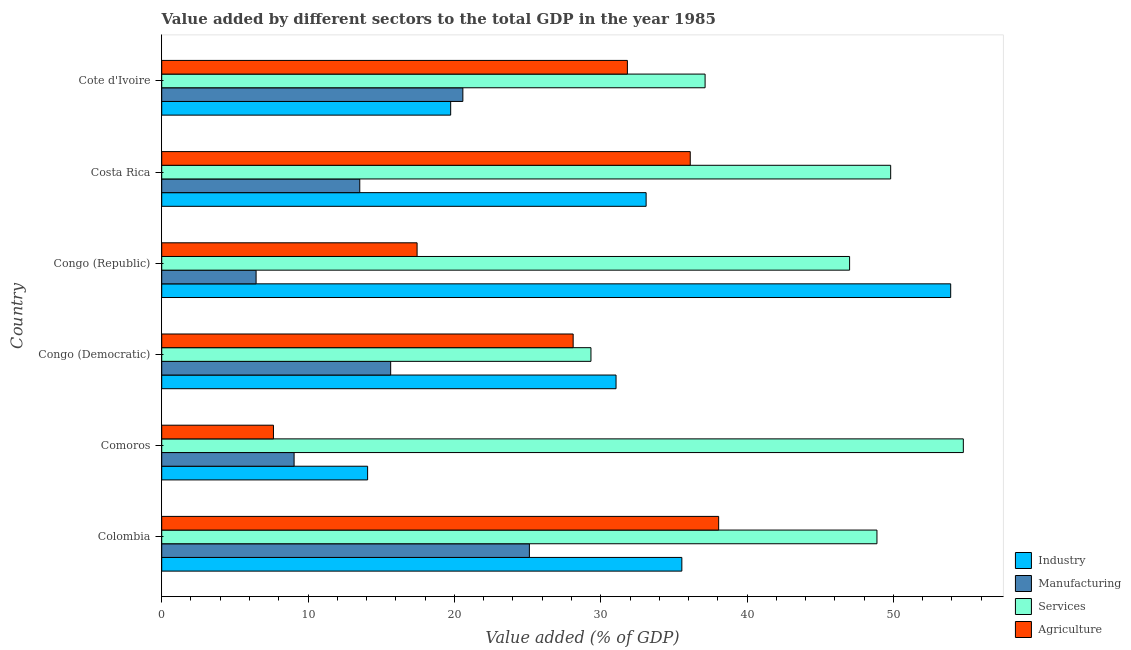How many different coloured bars are there?
Offer a very short reply. 4. How many groups of bars are there?
Your answer should be very brief. 6. What is the label of the 3rd group of bars from the top?
Your answer should be very brief. Congo (Republic). In how many cases, is the number of bars for a given country not equal to the number of legend labels?
Provide a short and direct response. 0. What is the value added by manufacturing sector in Colombia?
Your response must be concise. 25.12. Across all countries, what is the maximum value added by industrial sector?
Make the answer very short. 53.91. Across all countries, what is the minimum value added by services sector?
Your answer should be compact. 29.33. In which country was the value added by industrial sector maximum?
Your answer should be compact. Congo (Republic). In which country was the value added by industrial sector minimum?
Your answer should be very brief. Comoros. What is the total value added by manufacturing sector in the graph?
Provide a succinct answer. 90.38. What is the difference between the value added by industrial sector in Colombia and that in Congo (Democratic)?
Provide a succinct answer. 4.5. What is the difference between the value added by industrial sector in Costa Rica and the value added by services sector in Congo (Democratic)?
Your answer should be compact. 3.77. What is the average value added by services sector per country?
Your response must be concise. 44.49. What is the difference between the value added by industrial sector and value added by services sector in Cote d'Ivoire?
Keep it short and to the point. -17.39. In how many countries, is the value added by industrial sector greater than 4 %?
Provide a succinct answer. 6. What is the ratio of the value added by agricultural sector in Congo (Democratic) to that in Costa Rica?
Offer a terse response. 0.78. What is the difference between the highest and the second highest value added by services sector?
Offer a very short reply. 4.96. What is the difference between the highest and the lowest value added by agricultural sector?
Your answer should be compact. 30.42. Is the sum of the value added by agricultural sector in Congo (Democratic) and Cote d'Ivoire greater than the maximum value added by manufacturing sector across all countries?
Provide a succinct answer. Yes. What does the 1st bar from the top in Costa Rica represents?
Provide a short and direct response. Agriculture. What does the 1st bar from the bottom in Comoros represents?
Provide a short and direct response. Industry. Is it the case that in every country, the sum of the value added by industrial sector and value added by manufacturing sector is greater than the value added by services sector?
Your answer should be very brief. No. How many bars are there?
Give a very brief answer. 24. How many countries are there in the graph?
Your response must be concise. 6. What is the difference between two consecutive major ticks on the X-axis?
Your response must be concise. 10. Does the graph contain any zero values?
Give a very brief answer. No. Does the graph contain grids?
Give a very brief answer. No. How many legend labels are there?
Make the answer very short. 4. What is the title of the graph?
Ensure brevity in your answer.  Value added by different sectors to the total GDP in the year 1985. What is the label or title of the X-axis?
Give a very brief answer. Value added (% of GDP). What is the label or title of the Y-axis?
Your answer should be very brief. Country. What is the Value added (% of GDP) in Industry in Colombia?
Your response must be concise. 35.54. What is the Value added (% of GDP) in Manufacturing in Colombia?
Your answer should be compact. 25.12. What is the Value added (% of GDP) of Services in Colombia?
Provide a succinct answer. 48.88. What is the Value added (% of GDP) of Agriculture in Colombia?
Ensure brevity in your answer.  38.06. What is the Value added (% of GDP) of Industry in Comoros?
Offer a very short reply. 14.07. What is the Value added (% of GDP) in Manufacturing in Comoros?
Provide a short and direct response. 9.05. What is the Value added (% of GDP) of Services in Comoros?
Your answer should be compact. 54.78. What is the Value added (% of GDP) in Agriculture in Comoros?
Offer a terse response. 7.64. What is the Value added (% of GDP) of Industry in Congo (Democratic)?
Make the answer very short. 31.05. What is the Value added (% of GDP) in Manufacturing in Congo (Democratic)?
Give a very brief answer. 15.65. What is the Value added (% of GDP) of Services in Congo (Democratic)?
Make the answer very short. 29.33. What is the Value added (% of GDP) in Agriculture in Congo (Democratic)?
Provide a short and direct response. 28.12. What is the Value added (% of GDP) in Industry in Congo (Republic)?
Your response must be concise. 53.91. What is the Value added (% of GDP) in Manufacturing in Congo (Republic)?
Offer a very short reply. 6.45. What is the Value added (% of GDP) in Services in Congo (Republic)?
Your answer should be very brief. 47.01. What is the Value added (% of GDP) of Agriculture in Congo (Republic)?
Your answer should be compact. 17.45. What is the Value added (% of GDP) of Industry in Costa Rica?
Keep it short and to the point. 33.1. What is the Value added (% of GDP) of Manufacturing in Costa Rica?
Ensure brevity in your answer.  13.53. What is the Value added (% of GDP) of Services in Costa Rica?
Give a very brief answer. 49.81. What is the Value added (% of GDP) in Agriculture in Costa Rica?
Your answer should be very brief. 36.12. What is the Value added (% of GDP) in Industry in Cote d'Ivoire?
Provide a short and direct response. 19.75. What is the Value added (% of GDP) in Manufacturing in Cote d'Ivoire?
Offer a very short reply. 20.58. What is the Value added (% of GDP) in Services in Cote d'Ivoire?
Your answer should be compact. 37.13. What is the Value added (% of GDP) of Agriculture in Cote d'Ivoire?
Keep it short and to the point. 31.82. Across all countries, what is the maximum Value added (% of GDP) of Industry?
Ensure brevity in your answer.  53.91. Across all countries, what is the maximum Value added (% of GDP) in Manufacturing?
Ensure brevity in your answer.  25.12. Across all countries, what is the maximum Value added (% of GDP) in Services?
Make the answer very short. 54.78. Across all countries, what is the maximum Value added (% of GDP) in Agriculture?
Make the answer very short. 38.06. Across all countries, what is the minimum Value added (% of GDP) of Industry?
Offer a very short reply. 14.07. Across all countries, what is the minimum Value added (% of GDP) of Manufacturing?
Your response must be concise. 6.45. Across all countries, what is the minimum Value added (% of GDP) in Services?
Keep it short and to the point. 29.33. Across all countries, what is the minimum Value added (% of GDP) in Agriculture?
Provide a short and direct response. 7.64. What is the total Value added (% of GDP) of Industry in the graph?
Offer a very short reply. 187.42. What is the total Value added (% of GDP) in Manufacturing in the graph?
Ensure brevity in your answer.  90.38. What is the total Value added (% of GDP) of Services in the graph?
Keep it short and to the point. 266.94. What is the total Value added (% of GDP) of Agriculture in the graph?
Provide a short and direct response. 159.2. What is the difference between the Value added (% of GDP) of Industry in Colombia and that in Comoros?
Offer a very short reply. 21.47. What is the difference between the Value added (% of GDP) of Manufacturing in Colombia and that in Comoros?
Ensure brevity in your answer.  16.08. What is the difference between the Value added (% of GDP) in Services in Colombia and that in Comoros?
Provide a succinct answer. -5.9. What is the difference between the Value added (% of GDP) in Agriculture in Colombia and that in Comoros?
Offer a terse response. 30.42. What is the difference between the Value added (% of GDP) in Industry in Colombia and that in Congo (Democratic)?
Give a very brief answer. 4.5. What is the difference between the Value added (% of GDP) in Manufacturing in Colombia and that in Congo (Democratic)?
Your answer should be very brief. 9.48. What is the difference between the Value added (% of GDP) in Services in Colombia and that in Congo (Democratic)?
Offer a very short reply. 19.54. What is the difference between the Value added (% of GDP) of Agriculture in Colombia and that in Congo (Democratic)?
Your answer should be compact. 9.94. What is the difference between the Value added (% of GDP) in Industry in Colombia and that in Congo (Republic)?
Your answer should be compact. -18.37. What is the difference between the Value added (% of GDP) in Manufacturing in Colombia and that in Congo (Republic)?
Your answer should be very brief. 18.68. What is the difference between the Value added (% of GDP) in Services in Colombia and that in Congo (Republic)?
Provide a succinct answer. 1.87. What is the difference between the Value added (% of GDP) of Agriculture in Colombia and that in Congo (Republic)?
Your answer should be compact. 20.61. What is the difference between the Value added (% of GDP) in Industry in Colombia and that in Costa Rica?
Your answer should be compact. 2.44. What is the difference between the Value added (% of GDP) of Manufacturing in Colombia and that in Costa Rica?
Offer a very short reply. 11.59. What is the difference between the Value added (% of GDP) of Services in Colombia and that in Costa Rica?
Ensure brevity in your answer.  -0.94. What is the difference between the Value added (% of GDP) of Agriculture in Colombia and that in Costa Rica?
Provide a short and direct response. 1.94. What is the difference between the Value added (% of GDP) of Industry in Colombia and that in Cote d'Ivoire?
Keep it short and to the point. 15.8. What is the difference between the Value added (% of GDP) in Manufacturing in Colombia and that in Cote d'Ivoire?
Your answer should be very brief. 4.55. What is the difference between the Value added (% of GDP) of Services in Colombia and that in Cote d'Ivoire?
Keep it short and to the point. 11.74. What is the difference between the Value added (% of GDP) of Agriculture in Colombia and that in Cote d'Ivoire?
Provide a succinct answer. 6.24. What is the difference between the Value added (% of GDP) in Industry in Comoros and that in Congo (Democratic)?
Your answer should be very brief. -16.98. What is the difference between the Value added (% of GDP) in Manufacturing in Comoros and that in Congo (Democratic)?
Your response must be concise. -6.6. What is the difference between the Value added (% of GDP) in Services in Comoros and that in Congo (Democratic)?
Give a very brief answer. 25.45. What is the difference between the Value added (% of GDP) in Agriculture in Comoros and that in Congo (Democratic)?
Your response must be concise. -20.48. What is the difference between the Value added (% of GDP) of Industry in Comoros and that in Congo (Republic)?
Provide a short and direct response. -39.84. What is the difference between the Value added (% of GDP) of Manufacturing in Comoros and that in Congo (Republic)?
Offer a very short reply. 2.6. What is the difference between the Value added (% of GDP) of Services in Comoros and that in Congo (Republic)?
Make the answer very short. 7.77. What is the difference between the Value added (% of GDP) of Agriculture in Comoros and that in Congo (Republic)?
Your answer should be very brief. -9.82. What is the difference between the Value added (% of GDP) of Industry in Comoros and that in Costa Rica?
Your response must be concise. -19.03. What is the difference between the Value added (% of GDP) in Manufacturing in Comoros and that in Costa Rica?
Keep it short and to the point. -4.49. What is the difference between the Value added (% of GDP) in Services in Comoros and that in Costa Rica?
Make the answer very short. 4.96. What is the difference between the Value added (% of GDP) of Agriculture in Comoros and that in Costa Rica?
Give a very brief answer. -28.48. What is the difference between the Value added (% of GDP) of Industry in Comoros and that in Cote d'Ivoire?
Provide a succinct answer. -5.68. What is the difference between the Value added (% of GDP) of Manufacturing in Comoros and that in Cote d'Ivoire?
Your response must be concise. -11.53. What is the difference between the Value added (% of GDP) of Services in Comoros and that in Cote d'Ivoire?
Provide a succinct answer. 17.65. What is the difference between the Value added (% of GDP) of Agriculture in Comoros and that in Cote d'Ivoire?
Make the answer very short. -24.19. What is the difference between the Value added (% of GDP) in Industry in Congo (Democratic) and that in Congo (Republic)?
Keep it short and to the point. -22.87. What is the difference between the Value added (% of GDP) in Manufacturing in Congo (Democratic) and that in Congo (Republic)?
Make the answer very short. 9.2. What is the difference between the Value added (% of GDP) of Services in Congo (Democratic) and that in Congo (Republic)?
Give a very brief answer. -17.67. What is the difference between the Value added (% of GDP) of Agriculture in Congo (Democratic) and that in Congo (Republic)?
Give a very brief answer. 10.66. What is the difference between the Value added (% of GDP) of Industry in Congo (Democratic) and that in Costa Rica?
Your response must be concise. -2.06. What is the difference between the Value added (% of GDP) of Manufacturing in Congo (Democratic) and that in Costa Rica?
Ensure brevity in your answer.  2.11. What is the difference between the Value added (% of GDP) of Services in Congo (Democratic) and that in Costa Rica?
Your answer should be compact. -20.48. What is the difference between the Value added (% of GDP) of Agriculture in Congo (Democratic) and that in Costa Rica?
Offer a very short reply. -8. What is the difference between the Value added (% of GDP) of Industry in Congo (Democratic) and that in Cote d'Ivoire?
Ensure brevity in your answer.  11.3. What is the difference between the Value added (% of GDP) in Manufacturing in Congo (Democratic) and that in Cote d'Ivoire?
Ensure brevity in your answer.  -4.93. What is the difference between the Value added (% of GDP) in Services in Congo (Democratic) and that in Cote d'Ivoire?
Give a very brief answer. -7.8. What is the difference between the Value added (% of GDP) in Agriculture in Congo (Democratic) and that in Cote d'Ivoire?
Make the answer very short. -3.71. What is the difference between the Value added (% of GDP) of Industry in Congo (Republic) and that in Costa Rica?
Your response must be concise. 20.81. What is the difference between the Value added (% of GDP) in Manufacturing in Congo (Republic) and that in Costa Rica?
Your answer should be very brief. -7.08. What is the difference between the Value added (% of GDP) of Services in Congo (Republic) and that in Costa Rica?
Your answer should be very brief. -2.81. What is the difference between the Value added (% of GDP) of Agriculture in Congo (Republic) and that in Costa Rica?
Ensure brevity in your answer.  -18.67. What is the difference between the Value added (% of GDP) in Industry in Congo (Republic) and that in Cote d'Ivoire?
Keep it short and to the point. 34.17. What is the difference between the Value added (% of GDP) of Manufacturing in Congo (Republic) and that in Cote d'Ivoire?
Provide a short and direct response. -14.13. What is the difference between the Value added (% of GDP) of Services in Congo (Republic) and that in Cote d'Ivoire?
Your answer should be very brief. 9.87. What is the difference between the Value added (% of GDP) of Agriculture in Congo (Republic) and that in Cote d'Ivoire?
Provide a short and direct response. -14.37. What is the difference between the Value added (% of GDP) in Industry in Costa Rica and that in Cote d'Ivoire?
Make the answer very short. 13.36. What is the difference between the Value added (% of GDP) in Manufacturing in Costa Rica and that in Cote d'Ivoire?
Keep it short and to the point. -7.04. What is the difference between the Value added (% of GDP) of Services in Costa Rica and that in Cote d'Ivoire?
Ensure brevity in your answer.  12.68. What is the difference between the Value added (% of GDP) in Agriculture in Costa Rica and that in Cote d'Ivoire?
Offer a terse response. 4.3. What is the difference between the Value added (% of GDP) in Industry in Colombia and the Value added (% of GDP) in Manufacturing in Comoros?
Ensure brevity in your answer.  26.5. What is the difference between the Value added (% of GDP) of Industry in Colombia and the Value added (% of GDP) of Services in Comoros?
Offer a terse response. -19.24. What is the difference between the Value added (% of GDP) of Industry in Colombia and the Value added (% of GDP) of Agriculture in Comoros?
Keep it short and to the point. 27.91. What is the difference between the Value added (% of GDP) in Manufacturing in Colombia and the Value added (% of GDP) in Services in Comoros?
Ensure brevity in your answer.  -29.65. What is the difference between the Value added (% of GDP) of Manufacturing in Colombia and the Value added (% of GDP) of Agriculture in Comoros?
Provide a short and direct response. 17.49. What is the difference between the Value added (% of GDP) of Services in Colombia and the Value added (% of GDP) of Agriculture in Comoros?
Offer a terse response. 41.24. What is the difference between the Value added (% of GDP) of Industry in Colombia and the Value added (% of GDP) of Manufacturing in Congo (Democratic)?
Make the answer very short. 19.9. What is the difference between the Value added (% of GDP) in Industry in Colombia and the Value added (% of GDP) in Services in Congo (Democratic)?
Offer a very short reply. 6.21. What is the difference between the Value added (% of GDP) in Industry in Colombia and the Value added (% of GDP) in Agriculture in Congo (Democratic)?
Your answer should be very brief. 7.43. What is the difference between the Value added (% of GDP) of Manufacturing in Colombia and the Value added (% of GDP) of Services in Congo (Democratic)?
Ensure brevity in your answer.  -4.21. What is the difference between the Value added (% of GDP) of Manufacturing in Colombia and the Value added (% of GDP) of Agriculture in Congo (Democratic)?
Make the answer very short. -2.99. What is the difference between the Value added (% of GDP) in Services in Colombia and the Value added (% of GDP) in Agriculture in Congo (Democratic)?
Offer a very short reply. 20.76. What is the difference between the Value added (% of GDP) in Industry in Colombia and the Value added (% of GDP) in Manufacturing in Congo (Republic)?
Make the answer very short. 29.09. What is the difference between the Value added (% of GDP) in Industry in Colombia and the Value added (% of GDP) in Services in Congo (Republic)?
Provide a short and direct response. -11.46. What is the difference between the Value added (% of GDP) of Industry in Colombia and the Value added (% of GDP) of Agriculture in Congo (Republic)?
Give a very brief answer. 18.09. What is the difference between the Value added (% of GDP) in Manufacturing in Colombia and the Value added (% of GDP) in Services in Congo (Republic)?
Your answer should be compact. -21.88. What is the difference between the Value added (% of GDP) of Manufacturing in Colombia and the Value added (% of GDP) of Agriculture in Congo (Republic)?
Ensure brevity in your answer.  7.67. What is the difference between the Value added (% of GDP) in Services in Colombia and the Value added (% of GDP) in Agriculture in Congo (Republic)?
Make the answer very short. 31.42. What is the difference between the Value added (% of GDP) of Industry in Colombia and the Value added (% of GDP) of Manufacturing in Costa Rica?
Offer a very short reply. 22.01. What is the difference between the Value added (% of GDP) of Industry in Colombia and the Value added (% of GDP) of Services in Costa Rica?
Provide a succinct answer. -14.27. What is the difference between the Value added (% of GDP) of Industry in Colombia and the Value added (% of GDP) of Agriculture in Costa Rica?
Your answer should be very brief. -0.57. What is the difference between the Value added (% of GDP) of Manufacturing in Colombia and the Value added (% of GDP) of Services in Costa Rica?
Offer a very short reply. -24.69. What is the difference between the Value added (% of GDP) in Manufacturing in Colombia and the Value added (% of GDP) in Agriculture in Costa Rica?
Make the answer very short. -10.99. What is the difference between the Value added (% of GDP) of Services in Colombia and the Value added (% of GDP) of Agriculture in Costa Rica?
Keep it short and to the point. 12.76. What is the difference between the Value added (% of GDP) in Industry in Colombia and the Value added (% of GDP) in Manufacturing in Cote d'Ivoire?
Keep it short and to the point. 14.96. What is the difference between the Value added (% of GDP) in Industry in Colombia and the Value added (% of GDP) in Services in Cote d'Ivoire?
Your answer should be very brief. -1.59. What is the difference between the Value added (% of GDP) of Industry in Colombia and the Value added (% of GDP) of Agriculture in Cote d'Ivoire?
Offer a very short reply. 3.72. What is the difference between the Value added (% of GDP) in Manufacturing in Colombia and the Value added (% of GDP) in Services in Cote d'Ivoire?
Your answer should be very brief. -12.01. What is the difference between the Value added (% of GDP) in Manufacturing in Colombia and the Value added (% of GDP) in Agriculture in Cote d'Ivoire?
Your answer should be compact. -6.7. What is the difference between the Value added (% of GDP) in Services in Colombia and the Value added (% of GDP) in Agriculture in Cote d'Ivoire?
Make the answer very short. 17.05. What is the difference between the Value added (% of GDP) in Industry in Comoros and the Value added (% of GDP) in Manufacturing in Congo (Democratic)?
Your response must be concise. -1.58. What is the difference between the Value added (% of GDP) in Industry in Comoros and the Value added (% of GDP) in Services in Congo (Democratic)?
Provide a short and direct response. -15.26. What is the difference between the Value added (% of GDP) in Industry in Comoros and the Value added (% of GDP) in Agriculture in Congo (Democratic)?
Offer a very short reply. -14.05. What is the difference between the Value added (% of GDP) of Manufacturing in Comoros and the Value added (% of GDP) of Services in Congo (Democratic)?
Offer a terse response. -20.29. What is the difference between the Value added (% of GDP) in Manufacturing in Comoros and the Value added (% of GDP) in Agriculture in Congo (Democratic)?
Keep it short and to the point. -19.07. What is the difference between the Value added (% of GDP) of Services in Comoros and the Value added (% of GDP) of Agriculture in Congo (Democratic)?
Your answer should be compact. 26.66. What is the difference between the Value added (% of GDP) in Industry in Comoros and the Value added (% of GDP) in Manufacturing in Congo (Republic)?
Provide a succinct answer. 7.62. What is the difference between the Value added (% of GDP) in Industry in Comoros and the Value added (% of GDP) in Services in Congo (Republic)?
Your response must be concise. -32.94. What is the difference between the Value added (% of GDP) of Industry in Comoros and the Value added (% of GDP) of Agriculture in Congo (Republic)?
Provide a short and direct response. -3.38. What is the difference between the Value added (% of GDP) of Manufacturing in Comoros and the Value added (% of GDP) of Services in Congo (Republic)?
Offer a very short reply. -37.96. What is the difference between the Value added (% of GDP) in Manufacturing in Comoros and the Value added (% of GDP) in Agriculture in Congo (Republic)?
Your response must be concise. -8.41. What is the difference between the Value added (% of GDP) in Services in Comoros and the Value added (% of GDP) in Agriculture in Congo (Republic)?
Provide a short and direct response. 37.33. What is the difference between the Value added (% of GDP) of Industry in Comoros and the Value added (% of GDP) of Manufacturing in Costa Rica?
Your answer should be very brief. 0.54. What is the difference between the Value added (% of GDP) in Industry in Comoros and the Value added (% of GDP) in Services in Costa Rica?
Keep it short and to the point. -35.74. What is the difference between the Value added (% of GDP) in Industry in Comoros and the Value added (% of GDP) in Agriculture in Costa Rica?
Make the answer very short. -22.05. What is the difference between the Value added (% of GDP) in Manufacturing in Comoros and the Value added (% of GDP) in Services in Costa Rica?
Offer a terse response. -40.77. What is the difference between the Value added (% of GDP) in Manufacturing in Comoros and the Value added (% of GDP) in Agriculture in Costa Rica?
Your response must be concise. -27.07. What is the difference between the Value added (% of GDP) of Services in Comoros and the Value added (% of GDP) of Agriculture in Costa Rica?
Ensure brevity in your answer.  18.66. What is the difference between the Value added (% of GDP) in Industry in Comoros and the Value added (% of GDP) in Manufacturing in Cote d'Ivoire?
Offer a very short reply. -6.51. What is the difference between the Value added (% of GDP) in Industry in Comoros and the Value added (% of GDP) in Services in Cote d'Ivoire?
Provide a succinct answer. -23.06. What is the difference between the Value added (% of GDP) of Industry in Comoros and the Value added (% of GDP) of Agriculture in Cote d'Ivoire?
Ensure brevity in your answer.  -17.75. What is the difference between the Value added (% of GDP) in Manufacturing in Comoros and the Value added (% of GDP) in Services in Cote d'Ivoire?
Keep it short and to the point. -28.09. What is the difference between the Value added (% of GDP) in Manufacturing in Comoros and the Value added (% of GDP) in Agriculture in Cote d'Ivoire?
Your response must be concise. -22.78. What is the difference between the Value added (% of GDP) in Services in Comoros and the Value added (% of GDP) in Agriculture in Cote d'Ivoire?
Your answer should be very brief. 22.96. What is the difference between the Value added (% of GDP) of Industry in Congo (Democratic) and the Value added (% of GDP) of Manufacturing in Congo (Republic)?
Your response must be concise. 24.6. What is the difference between the Value added (% of GDP) of Industry in Congo (Democratic) and the Value added (% of GDP) of Services in Congo (Republic)?
Your response must be concise. -15.96. What is the difference between the Value added (% of GDP) in Industry in Congo (Democratic) and the Value added (% of GDP) in Agriculture in Congo (Republic)?
Your answer should be compact. 13.59. What is the difference between the Value added (% of GDP) of Manufacturing in Congo (Democratic) and the Value added (% of GDP) of Services in Congo (Republic)?
Provide a succinct answer. -31.36. What is the difference between the Value added (% of GDP) of Manufacturing in Congo (Democratic) and the Value added (% of GDP) of Agriculture in Congo (Republic)?
Your answer should be very brief. -1.81. What is the difference between the Value added (% of GDP) in Services in Congo (Democratic) and the Value added (% of GDP) in Agriculture in Congo (Republic)?
Your response must be concise. 11.88. What is the difference between the Value added (% of GDP) of Industry in Congo (Democratic) and the Value added (% of GDP) of Manufacturing in Costa Rica?
Your answer should be compact. 17.51. What is the difference between the Value added (% of GDP) in Industry in Congo (Democratic) and the Value added (% of GDP) in Services in Costa Rica?
Provide a succinct answer. -18.77. What is the difference between the Value added (% of GDP) in Industry in Congo (Democratic) and the Value added (% of GDP) in Agriculture in Costa Rica?
Offer a very short reply. -5.07. What is the difference between the Value added (% of GDP) in Manufacturing in Congo (Democratic) and the Value added (% of GDP) in Services in Costa Rica?
Provide a short and direct response. -34.17. What is the difference between the Value added (% of GDP) of Manufacturing in Congo (Democratic) and the Value added (% of GDP) of Agriculture in Costa Rica?
Your answer should be very brief. -20.47. What is the difference between the Value added (% of GDP) of Services in Congo (Democratic) and the Value added (% of GDP) of Agriculture in Costa Rica?
Ensure brevity in your answer.  -6.78. What is the difference between the Value added (% of GDP) in Industry in Congo (Democratic) and the Value added (% of GDP) in Manufacturing in Cote d'Ivoire?
Your response must be concise. 10.47. What is the difference between the Value added (% of GDP) in Industry in Congo (Democratic) and the Value added (% of GDP) in Services in Cote d'Ivoire?
Give a very brief answer. -6.09. What is the difference between the Value added (% of GDP) in Industry in Congo (Democratic) and the Value added (% of GDP) in Agriculture in Cote d'Ivoire?
Your response must be concise. -0.78. What is the difference between the Value added (% of GDP) of Manufacturing in Congo (Democratic) and the Value added (% of GDP) of Services in Cote d'Ivoire?
Give a very brief answer. -21.49. What is the difference between the Value added (% of GDP) of Manufacturing in Congo (Democratic) and the Value added (% of GDP) of Agriculture in Cote d'Ivoire?
Provide a short and direct response. -16.18. What is the difference between the Value added (% of GDP) in Services in Congo (Democratic) and the Value added (% of GDP) in Agriculture in Cote d'Ivoire?
Your answer should be compact. -2.49. What is the difference between the Value added (% of GDP) in Industry in Congo (Republic) and the Value added (% of GDP) in Manufacturing in Costa Rica?
Provide a succinct answer. 40.38. What is the difference between the Value added (% of GDP) in Industry in Congo (Republic) and the Value added (% of GDP) in Services in Costa Rica?
Offer a terse response. 4.1. What is the difference between the Value added (% of GDP) in Industry in Congo (Republic) and the Value added (% of GDP) in Agriculture in Costa Rica?
Offer a terse response. 17.8. What is the difference between the Value added (% of GDP) in Manufacturing in Congo (Republic) and the Value added (% of GDP) in Services in Costa Rica?
Offer a terse response. -43.36. What is the difference between the Value added (% of GDP) in Manufacturing in Congo (Republic) and the Value added (% of GDP) in Agriculture in Costa Rica?
Offer a very short reply. -29.67. What is the difference between the Value added (% of GDP) of Services in Congo (Republic) and the Value added (% of GDP) of Agriculture in Costa Rica?
Give a very brief answer. 10.89. What is the difference between the Value added (% of GDP) in Industry in Congo (Republic) and the Value added (% of GDP) in Manufacturing in Cote d'Ivoire?
Give a very brief answer. 33.34. What is the difference between the Value added (% of GDP) in Industry in Congo (Republic) and the Value added (% of GDP) in Services in Cote d'Ivoire?
Ensure brevity in your answer.  16.78. What is the difference between the Value added (% of GDP) of Industry in Congo (Republic) and the Value added (% of GDP) of Agriculture in Cote d'Ivoire?
Offer a terse response. 22.09. What is the difference between the Value added (% of GDP) of Manufacturing in Congo (Republic) and the Value added (% of GDP) of Services in Cote d'Ivoire?
Provide a short and direct response. -30.68. What is the difference between the Value added (% of GDP) of Manufacturing in Congo (Republic) and the Value added (% of GDP) of Agriculture in Cote d'Ivoire?
Offer a terse response. -25.37. What is the difference between the Value added (% of GDP) of Services in Congo (Republic) and the Value added (% of GDP) of Agriculture in Cote d'Ivoire?
Your answer should be compact. 15.18. What is the difference between the Value added (% of GDP) in Industry in Costa Rica and the Value added (% of GDP) in Manufacturing in Cote d'Ivoire?
Keep it short and to the point. 12.52. What is the difference between the Value added (% of GDP) in Industry in Costa Rica and the Value added (% of GDP) in Services in Cote d'Ivoire?
Provide a succinct answer. -4.03. What is the difference between the Value added (% of GDP) of Industry in Costa Rica and the Value added (% of GDP) of Agriculture in Cote d'Ivoire?
Keep it short and to the point. 1.28. What is the difference between the Value added (% of GDP) of Manufacturing in Costa Rica and the Value added (% of GDP) of Services in Cote d'Ivoire?
Your answer should be compact. -23.6. What is the difference between the Value added (% of GDP) of Manufacturing in Costa Rica and the Value added (% of GDP) of Agriculture in Cote d'Ivoire?
Make the answer very short. -18.29. What is the difference between the Value added (% of GDP) in Services in Costa Rica and the Value added (% of GDP) in Agriculture in Cote d'Ivoire?
Ensure brevity in your answer.  17.99. What is the average Value added (% of GDP) of Industry per country?
Your answer should be compact. 31.24. What is the average Value added (% of GDP) of Manufacturing per country?
Ensure brevity in your answer.  15.06. What is the average Value added (% of GDP) in Services per country?
Provide a succinct answer. 44.49. What is the average Value added (% of GDP) in Agriculture per country?
Offer a very short reply. 26.53. What is the difference between the Value added (% of GDP) in Industry and Value added (% of GDP) in Manufacturing in Colombia?
Offer a terse response. 10.42. What is the difference between the Value added (% of GDP) in Industry and Value added (% of GDP) in Services in Colombia?
Offer a terse response. -13.33. What is the difference between the Value added (% of GDP) of Industry and Value added (% of GDP) of Agriculture in Colombia?
Give a very brief answer. -2.52. What is the difference between the Value added (% of GDP) in Manufacturing and Value added (% of GDP) in Services in Colombia?
Your response must be concise. -23.75. What is the difference between the Value added (% of GDP) in Manufacturing and Value added (% of GDP) in Agriculture in Colombia?
Make the answer very short. -12.93. What is the difference between the Value added (% of GDP) of Services and Value added (% of GDP) of Agriculture in Colombia?
Provide a short and direct response. 10.82. What is the difference between the Value added (% of GDP) in Industry and Value added (% of GDP) in Manufacturing in Comoros?
Your answer should be compact. 5.02. What is the difference between the Value added (% of GDP) of Industry and Value added (% of GDP) of Services in Comoros?
Ensure brevity in your answer.  -40.71. What is the difference between the Value added (% of GDP) in Industry and Value added (% of GDP) in Agriculture in Comoros?
Provide a succinct answer. 6.43. What is the difference between the Value added (% of GDP) in Manufacturing and Value added (% of GDP) in Services in Comoros?
Your answer should be compact. -45.73. What is the difference between the Value added (% of GDP) of Manufacturing and Value added (% of GDP) of Agriculture in Comoros?
Your response must be concise. 1.41. What is the difference between the Value added (% of GDP) in Services and Value added (% of GDP) in Agriculture in Comoros?
Provide a succinct answer. 47.14. What is the difference between the Value added (% of GDP) in Industry and Value added (% of GDP) in Manufacturing in Congo (Democratic)?
Ensure brevity in your answer.  15.4. What is the difference between the Value added (% of GDP) in Industry and Value added (% of GDP) in Services in Congo (Democratic)?
Make the answer very short. 1.71. What is the difference between the Value added (% of GDP) of Industry and Value added (% of GDP) of Agriculture in Congo (Democratic)?
Offer a very short reply. 2.93. What is the difference between the Value added (% of GDP) of Manufacturing and Value added (% of GDP) of Services in Congo (Democratic)?
Your answer should be very brief. -13.69. What is the difference between the Value added (% of GDP) in Manufacturing and Value added (% of GDP) in Agriculture in Congo (Democratic)?
Offer a very short reply. -12.47. What is the difference between the Value added (% of GDP) of Services and Value added (% of GDP) of Agriculture in Congo (Democratic)?
Offer a terse response. 1.22. What is the difference between the Value added (% of GDP) in Industry and Value added (% of GDP) in Manufacturing in Congo (Republic)?
Give a very brief answer. 47.47. What is the difference between the Value added (% of GDP) in Industry and Value added (% of GDP) in Services in Congo (Republic)?
Provide a succinct answer. 6.91. What is the difference between the Value added (% of GDP) in Industry and Value added (% of GDP) in Agriculture in Congo (Republic)?
Your answer should be compact. 36.46. What is the difference between the Value added (% of GDP) in Manufacturing and Value added (% of GDP) in Services in Congo (Republic)?
Your answer should be compact. -40.56. What is the difference between the Value added (% of GDP) in Manufacturing and Value added (% of GDP) in Agriculture in Congo (Republic)?
Offer a terse response. -11. What is the difference between the Value added (% of GDP) of Services and Value added (% of GDP) of Agriculture in Congo (Republic)?
Make the answer very short. 29.55. What is the difference between the Value added (% of GDP) in Industry and Value added (% of GDP) in Manufacturing in Costa Rica?
Give a very brief answer. 19.57. What is the difference between the Value added (% of GDP) in Industry and Value added (% of GDP) in Services in Costa Rica?
Your answer should be compact. -16.71. What is the difference between the Value added (% of GDP) of Industry and Value added (% of GDP) of Agriculture in Costa Rica?
Provide a short and direct response. -3.02. What is the difference between the Value added (% of GDP) of Manufacturing and Value added (% of GDP) of Services in Costa Rica?
Give a very brief answer. -36.28. What is the difference between the Value added (% of GDP) of Manufacturing and Value added (% of GDP) of Agriculture in Costa Rica?
Your answer should be compact. -22.58. What is the difference between the Value added (% of GDP) in Services and Value added (% of GDP) in Agriculture in Costa Rica?
Ensure brevity in your answer.  13.7. What is the difference between the Value added (% of GDP) of Industry and Value added (% of GDP) of Manufacturing in Cote d'Ivoire?
Give a very brief answer. -0.83. What is the difference between the Value added (% of GDP) in Industry and Value added (% of GDP) in Services in Cote d'Ivoire?
Provide a succinct answer. -17.39. What is the difference between the Value added (% of GDP) of Industry and Value added (% of GDP) of Agriculture in Cote d'Ivoire?
Provide a succinct answer. -12.08. What is the difference between the Value added (% of GDP) in Manufacturing and Value added (% of GDP) in Services in Cote d'Ivoire?
Give a very brief answer. -16.55. What is the difference between the Value added (% of GDP) of Manufacturing and Value added (% of GDP) of Agriculture in Cote d'Ivoire?
Provide a succinct answer. -11.24. What is the difference between the Value added (% of GDP) in Services and Value added (% of GDP) in Agriculture in Cote d'Ivoire?
Provide a short and direct response. 5.31. What is the ratio of the Value added (% of GDP) in Industry in Colombia to that in Comoros?
Give a very brief answer. 2.53. What is the ratio of the Value added (% of GDP) in Manufacturing in Colombia to that in Comoros?
Make the answer very short. 2.78. What is the ratio of the Value added (% of GDP) in Services in Colombia to that in Comoros?
Provide a short and direct response. 0.89. What is the ratio of the Value added (% of GDP) of Agriculture in Colombia to that in Comoros?
Keep it short and to the point. 4.98. What is the ratio of the Value added (% of GDP) in Industry in Colombia to that in Congo (Democratic)?
Provide a succinct answer. 1.14. What is the ratio of the Value added (% of GDP) of Manufacturing in Colombia to that in Congo (Democratic)?
Give a very brief answer. 1.61. What is the ratio of the Value added (% of GDP) in Services in Colombia to that in Congo (Democratic)?
Your answer should be compact. 1.67. What is the ratio of the Value added (% of GDP) in Agriculture in Colombia to that in Congo (Democratic)?
Offer a very short reply. 1.35. What is the ratio of the Value added (% of GDP) in Industry in Colombia to that in Congo (Republic)?
Provide a succinct answer. 0.66. What is the ratio of the Value added (% of GDP) of Manufacturing in Colombia to that in Congo (Republic)?
Give a very brief answer. 3.9. What is the ratio of the Value added (% of GDP) in Services in Colombia to that in Congo (Republic)?
Offer a very short reply. 1.04. What is the ratio of the Value added (% of GDP) of Agriculture in Colombia to that in Congo (Republic)?
Offer a very short reply. 2.18. What is the ratio of the Value added (% of GDP) of Industry in Colombia to that in Costa Rica?
Offer a very short reply. 1.07. What is the ratio of the Value added (% of GDP) of Manufacturing in Colombia to that in Costa Rica?
Keep it short and to the point. 1.86. What is the ratio of the Value added (% of GDP) of Services in Colombia to that in Costa Rica?
Ensure brevity in your answer.  0.98. What is the ratio of the Value added (% of GDP) in Agriculture in Colombia to that in Costa Rica?
Your answer should be compact. 1.05. What is the ratio of the Value added (% of GDP) in Industry in Colombia to that in Cote d'Ivoire?
Ensure brevity in your answer.  1.8. What is the ratio of the Value added (% of GDP) in Manufacturing in Colombia to that in Cote d'Ivoire?
Ensure brevity in your answer.  1.22. What is the ratio of the Value added (% of GDP) in Services in Colombia to that in Cote d'Ivoire?
Offer a terse response. 1.32. What is the ratio of the Value added (% of GDP) in Agriculture in Colombia to that in Cote d'Ivoire?
Your answer should be very brief. 1.2. What is the ratio of the Value added (% of GDP) in Industry in Comoros to that in Congo (Democratic)?
Keep it short and to the point. 0.45. What is the ratio of the Value added (% of GDP) of Manufacturing in Comoros to that in Congo (Democratic)?
Make the answer very short. 0.58. What is the ratio of the Value added (% of GDP) of Services in Comoros to that in Congo (Democratic)?
Make the answer very short. 1.87. What is the ratio of the Value added (% of GDP) in Agriculture in Comoros to that in Congo (Democratic)?
Your answer should be very brief. 0.27. What is the ratio of the Value added (% of GDP) in Industry in Comoros to that in Congo (Republic)?
Make the answer very short. 0.26. What is the ratio of the Value added (% of GDP) in Manufacturing in Comoros to that in Congo (Republic)?
Give a very brief answer. 1.4. What is the ratio of the Value added (% of GDP) of Services in Comoros to that in Congo (Republic)?
Your response must be concise. 1.17. What is the ratio of the Value added (% of GDP) in Agriculture in Comoros to that in Congo (Republic)?
Keep it short and to the point. 0.44. What is the ratio of the Value added (% of GDP) in Industry in Comoros to that in Costa Rica?
Your response must be concise. 0.43. What is the ratio of the Value added (% of GDP) in Manufacturing in Comoros to that in Costa Rica?
Ensure brevity in your answer.  0.67. What is the ratio of the Value added (% of GDP) in Services in Comoros to that in Costa Rica?
Make the answer very short. 1.1. What is the ratio of the Value added (% of GDP) in Agriculture in Comoros to that in Costa Rica?
Keep it short and to the point. 0.21. What is the ratio of the Value added (% of GDP) in Industry in Comoros to that in Cote d'Ivoire?
Make the answer very short. 0.71. What is the ratio of the Value added (% of GDP) of Manufacturing in Comoros to that in Cote d'Ivoire?
Your answer should be compact. 0.44. What is the ratio of the Value added (% of GDP) in Services in Comoros to that in Cote d'Ivoire?
Your answer should be very brief. 1.48. What is the ratio of the Value added (% of GDP) in Agriculture in Comoros to that in Cote d'Ivoire?
Your answer should be compact. 0.24. What is the ratio of the Value added (% of GDP) of Industry in Congo (Democratic) to that in Congo (Republic)?
Keep it short and to the point. 0.58. What is the ratio of the Value added (% of GDP) in Manufacturing in Congo (Democratic) to that in Congo (Republic)?
Your response must be concise. 2.43. What is the ratio of the Value added (% of GDP) of Services in Congo (Democratic) to that in Congo (Republic)?
Ensure brevity in your answer.  0.62. What is the ratio of the Value added (% of GDP) in Agriculture in Congo (Democratic) to that in Congo (Republic)?
Offer a terse response. 1.61. What is the ratio of the Value added (% of GDP) in Industry in Congo (Democratic) to that in Costa Rica?
Make the answer very short. 0.94. What is the ratio of the Value added (% of GDP) of Manufacturing in Congo (Democratic) to that in Costa Rica?
Offer a terse response. 1.16. What is the ratio of the Value added (% of GDP) of Services in Congo (Democratic) to that in Costa Rica?
Give a very brief answer. 0.59. What is the ratio of the Value added (% of GDP) of Agriculture in Congo (Democratic) to that in Costa Rica?
Provide a short and direct response. 0.78. What is the ratio of the Value added (% of GDP) in Industry in Congo (Democratic) to that in Cote d'Ivoire?
Offer a very short reply. 1.57. What is the ratio of the Value added (% of GDP) of Manufacturing in Congo (Democratic) to that in Cote d'Ivoire?
Provide a succinct answer. 0.76. What is the ratio of the Value added (% of GDP) in Services in Congo (Democratic) to that in Cote d'Ivoire?
Keep it short and to the point. 0.79. What is the ratio of the Value added (% of GDP) of Agriculture in Congo (Democratic) to that in Cote d'Ivoire?
Keep it short and to the point. 0.88. What is the ratio of the Value added (% of GDP) in Industry in Congo (Republic) to that in Costa Rica?
Keep it short and to the point. 1.63. What is the ratio of the Value added (% of GDP) in Manufacturing in Congo (Republic) to that in Costa Rica?
Your response must be concise. 0.48. What is the ratio of the Value added (% of GDP) of Services in Congo (Republic) to that in Costa Rica?
Give a very brief answer. 0.94. What is the ratio of the Value added (% of GDP) in Agriculture in Congo (Republic) to that in Costa Rica?
Give a very brief answer. 0.48. What is the ratio of the Value added (% of GDP) in Industry in Congo (Republic) to that in Cote d'Ivoire?
Give a very brief answer. 2.73. What is the ratio of the Value added (% of GDP) of Manufacturing in Congo (Republic) to that in Cote d'Ivoire?
Your response must be concise. 0.31. What is the ratio of the Value added (% of GDP) in Services in Congo (Republic) to that in Cote d'Ivoire?
Give a very brief answer. 1.27. What is the ratio of the Value added (% of GDP) of Agriculture in Congo (Republic) to that in Cote d'Ivoire?
Offer a very short reply. 0.55. What is the ratio of the Value added (% of GDP) of Industry in Costa Rica to that in Cote d'Ivoire?
Offer a terse response. 1.68. What is the ratio of the Value added (% of GDP) in Manufacturing in Costa Rica to that in Cote d'Ivoire?
Offer a very short reply. 0.66. What is the ratio of the Value added (% of GDP) in Services in Costa Rica to that in Cote d'Ivoire?
Your response must be concise. 1.34. What is the ratio of the Value added (% of GDP) of Agriculture in Costa Rica to that in Cote d'Ivoire?
Make the answer very short. 1.14. What is the difference between the highest and the second highest Value added (% of GDP) of Industry?
Offer a very short reply. 18.37. What is the difference between the highest and the second highest Value added (% of GDP) in Manufacturing?
Provide a succinct answer. 4.55. What is the difference between the highest and the second highest Value added (% of GDP) in Services?
Offer a terse response. 4.96. What is the difference between the highest and the second highest Value added (% of GDP) of Agriculture?
Ensure brevity in your answer.  1.94. What is the difference between the highest and the lowest Value added (% of GDP) of Industry?
Ensure brevity in your answer.  39.84. What is the difference between the highest and the lowest Value added (% of GDP) in Manufacturing?
Give a very brief answer. 18.68. What is the difference between the highest and the lowest Value added (% of GDP) in Services?
Your response must be concise. 25.45. What is the difference between the highest and the lowest Value added (% of GDP) in Agriculture?
Provide a short and direct response. 30.42. 